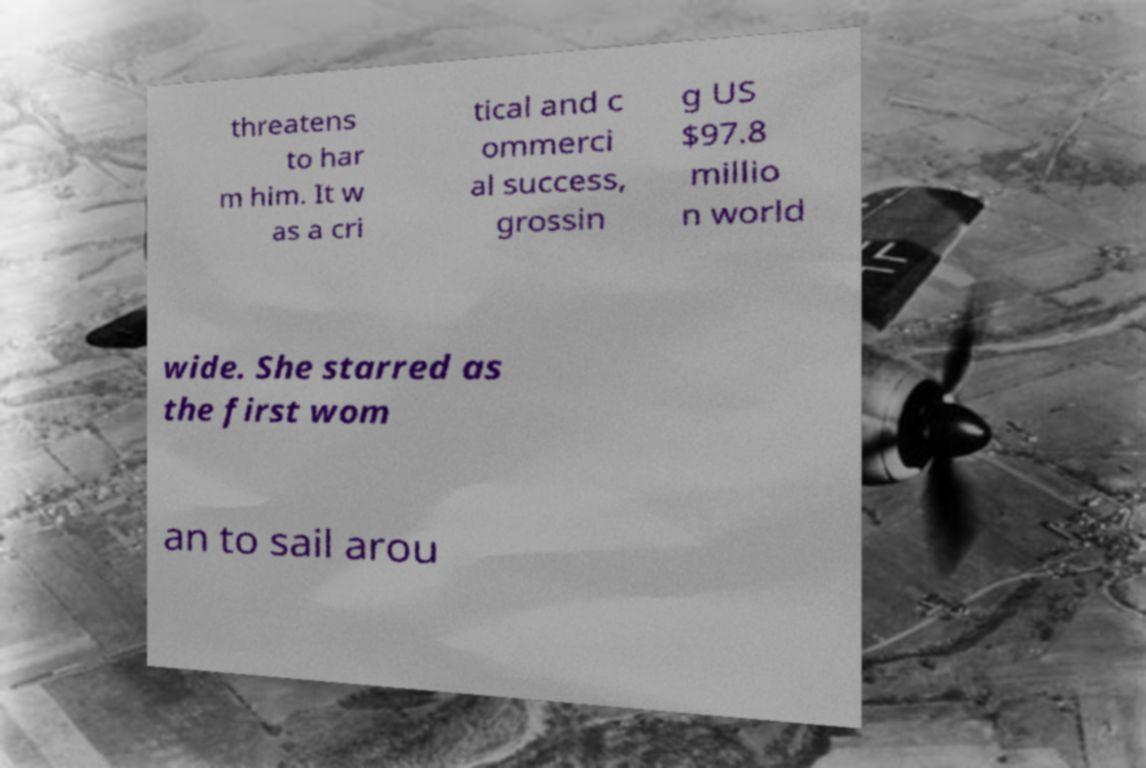Please read and relay the text visible in this image. What does it say? threatens to har m him. It w as a cri tical and c ommerci al success, grossin g US $97.8 millio n world wide. She starred as the first wom an to sail arou 